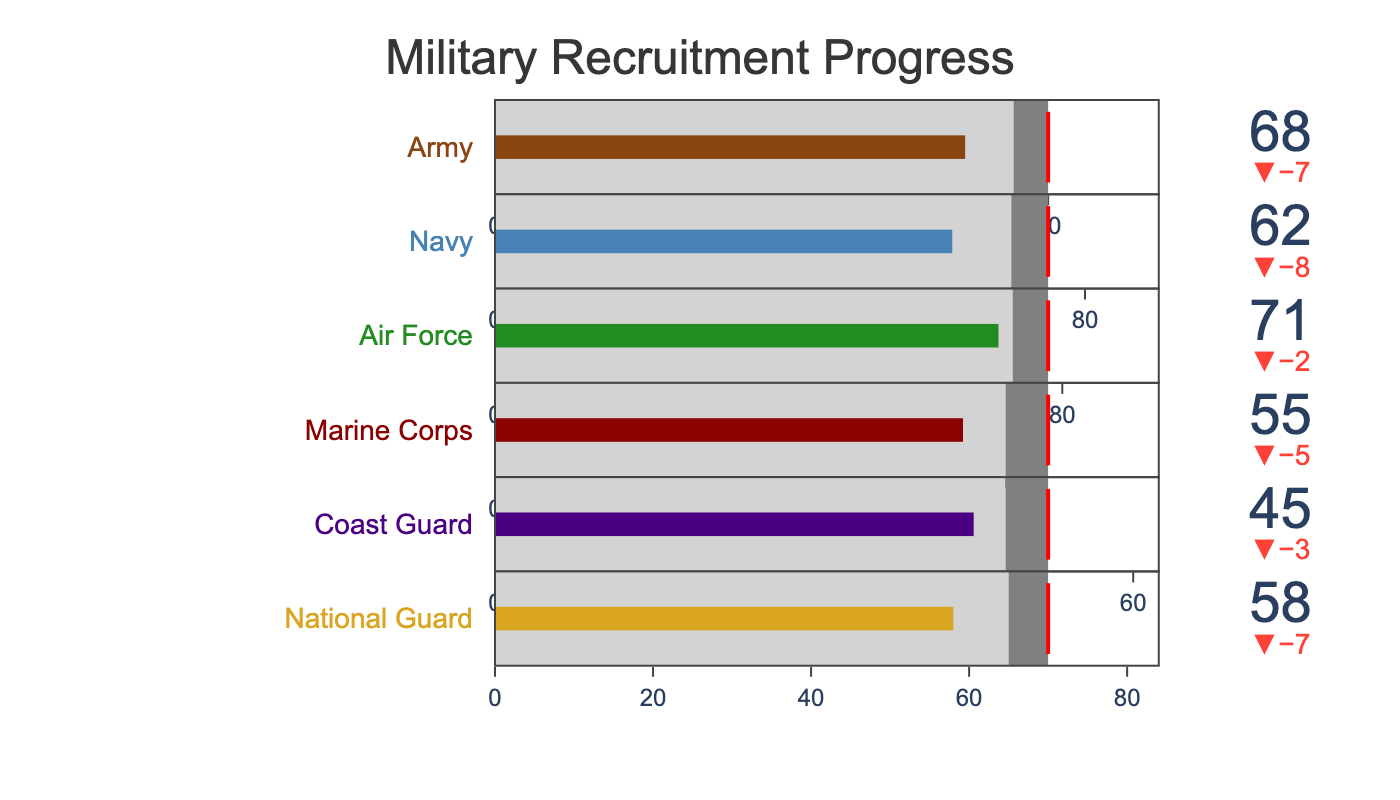what is the title of the chart? The title is usually displayed at the top of the chart, which helps viewers understand the main topic or purpose of the chart. In this case, the title can be found at the top center of the chart.
Answer: Military Recruitment Progress Which branch has the lowest current recruitment? Look at the bullet chart for each branch and identify the bar with the smallest value for current recruitment. The Coast Guard has the shortest bar at 45.
Answer: Coast Guard Is the Air Force's current recruitment higher or lower than its historical average? Compare the current recruitment value indicated by the bar to the historical average indicated by the first step in the bullet chart. The Air Force's current recruitment of 71 is lower than its historical average of 73.
Answer: Lower What is the target recruitment for the National Guard? The target recruitment is indicated by the red threshold line on the bullet chart for each branch. For the National Guard, the red line is set at 70.
Answer: 70 How much higher is the Army's target compared to its current recruitment? Subtract the Army's current recruitment value from its target value: 80 (target) - 68 (current recruitment).
Answer: 12 Which branches have a current recruitment lower than their historical average? Compare the current recruitment value to the historical average value for each branch. The branches with a current recruitment lower than their historical average are the Army, Navy, Marine Corps, Coast Guard, and National Guard.
Answer: Army, Navy, Marine Corps, Coast Guard, National Guard How does the Marine Corps’ current recruitment compare to the Coast Guard’s? Look at the current recruitment values for both branches. The Marine Corps has a current recruitment of 55 while the Coast Guard has 45, which means the Marine Corps' current recruitment is higher than the Coast Guard’s.
Answer: Higher What percentage of its target has the Navy achieved in its current recruitment? Divide the Navy's current recruitment by its target and multiply by 100: (62 / 75) * 100 = 82.67%.
Answer: 82.67% Which branch has exceeded its historical average in current recruitment? Identify which branches have a current recruitment value greater than their historical average. The Air Force, with a current recruitment of 71 and historical average of 73, is the branch that has exceeded its historical average.
Answer: Air Force What is the difference between the Army's historical average and the Marine Corps' current recruitment? Subtract the Marine Corps' current recruitment from the Army's historical average: 75 (Army's historical average) - 55 (Marine Corps' current recruitment).
Answer: 20 